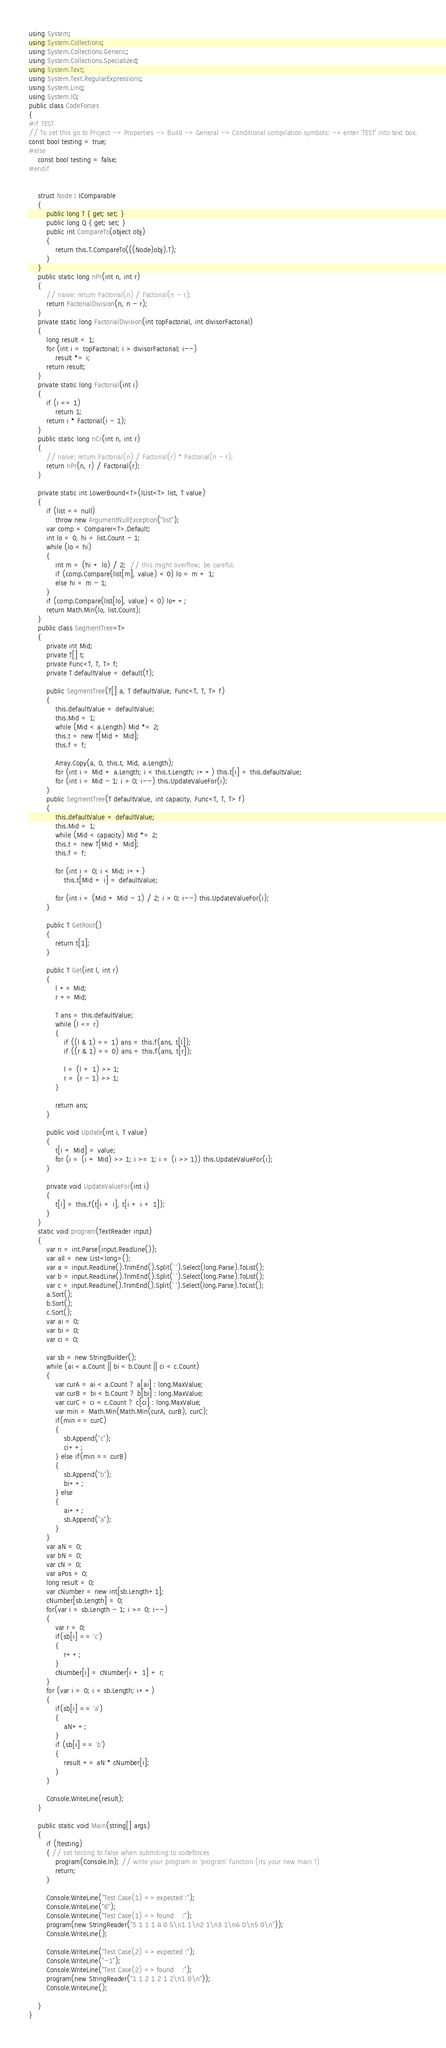<code> <loc_0><loc_0><loc_500><loc_500><_C#_>using System;
using System.Collections;
using System.Collections.Generic;
using System.Collections.Specialized;
using System.Text;
using System.Text.RegularExpressions;
using System.Linq;
using System.IO;
public class CodeForces
{
#if TEST
// To set this go to Project -> Properties -> Build -> General -> Conditional compilation symbols: -> enter 'TEST' into text box.
const bool testing = true;
#else
    const bool testing = false;
#endif


    struct Node : IComparable
    {
        public long T { get; set; }
        public long Q { get; set; }
        public int CompareTo(object obj)
        {
            return this.T.CompareTo(((Node)obj).T);
        }
    }
    public static long nPr(int n, int r)
    {
        // naive: return Factorial(n) / Factorial(n - r);
        return FactorialDivision(n, n - r);
    }
    private static long FactorialDivision(int topFactorial, int divisorFactorial)
    {
        long result = 1;
        for (int i = topFactorial; i > divisorFactorial; i--)
            result *= i;
        return result;
    }
    private static long Factorial(int i)
    {
        if (i <= 1)
            return 1;
        return i * Factorial(i - 1);
    }
    public static long nCr(int n, int r)
    {
        // naive: return Factorial(n) / Factorial(r) * Factorial(n - r);
        return nPr(n, r) / Factorial(r);
    }

    private static int LowerBound<T>(IList<T> list, T value)
    {
        if (list == null)
            throw new ArgumentNullException("list");
        var comp = Comparer<T>.Default;
        int lo = 0, hi = list.Count - 1;
        while (lo < hi)
        {
            int m = (hi + lo) / 2;  // this might overflow; be careful.
            if (comp.Compare(list[m], value) < 0) lo = m + 1;
            else hi = m - 1;
        }
        if (comp.Compare(list[lo], value) < 0) lo++;
        return Math.Min(lo, list.Count);
    }
    public class SegmentTree<T>
    {
        private int Mid;
        private T[] t;
        private Func<T, T, T> f;
        private T defaultValue = default(T);

        public SegmentTree(T[] a, T defaultValue, Func<T, T, T> f)
        {
            this.defaultValue = defaultValue;
            this.Mid = 1;
            while (Mid < a.Length) Mid *= 2;
            this.t = new T[Mid + Mid];
            this.f = f;

            Array.Copy(a, 0, this.t, Mid, a.Length);
            for (int i = Mid + a.Length; i < this.t.Length; i++) this.t[i] = this.defaultValue;
            for (int i = Mid - 1; i > 0; i--) this.UpdateValueFor(i);
        }
        public SegmentTree(T defaultValue, int capacity, Func<T, T, T> f)
        {
            this.defaultValue = defaultValue;
            this.Mid = 1;
            while (Mid < capacity) Mid *= 2;
            this.t = new T[Mid + Mid];
            this.f = f;

            for (int i = 0; i < Mid; i++)
                this.t[Mid + i] = defaultValue;

            for (int i = (Mid + Mid - 1) / 2; i > 0; i--) this.UpdateValueFor(i);
        }

        public T GetRoot()
        {
            return t[1];
        }

        public T Get(int l, int r)
        {
            l += Mid;
            r += Mid;

            T ans = this.defaultValue;
            while (l <= r)
            {
                if ((l & 1) == 1) ans = this.f(ans, t[l]);
                if ((r & 1) == 0) ans = this.f(ans, t[r]);

                l = (l + 1) >> 1;
                r = (r - 1) >> 1;
            }

            return ans;
        }

        public void Update(int i, T value)
        {
            t[i + Mid] = value;
            for (i = (i + Mid) >> 1; i >= 1; i = (i >> 1)) this.UpdateValueFor(i);
        }

        private void UpdateValueFor(int i)
        {
            t[i] = this.f(t[i + i], t[i + i + 1]);
        }
    }
    static void program(TextReader input)
    {
        var n = int.Parse(input.ReadLine());
        var all = new List<long>();
        var a = input.ReadLine().TrimEnd().Split(' ').Select(long.Parse).ToList();
        var b = input.ReadLine().TrimEnd().Split(' ').Select(long.Parse).ToList();
        var c = input.ReadLine().TrimEnd().Split(' ').Select(long.Parse).ToList();
        a.Sort();
        b.Sort();
        c.Sort();
        var ai = 0;
        var bi = 0;
        var ci = 0;
        
        var sb = new StringBuilder();
        while (ai < a.Count || bi < b.Count || ci < c.Count)
        {
            var curA = ai < a.Count ? a[ai] : long.MaxValue;
            var curB = bi < b.Count ? b[bi] : long.MaxValue;
            var curC = ci < c.Count ? c[ci] : long.MaxValue;
            var min = Math.Min(Math.Min(curA, curB), curC);
            if(min == curC)
            {
                sb.Append("c");
                ci++;
            } else if(min == curB)
            {
                sb.Append("b");
                bi++;
            } else
            {
                ai++;
                sb.Append("a");
            }
        }
        var aN = 0;
        var bN = 0;
        var cN = 0;
        var aPos = 0;
        long result = 0;
        var cNumber = new int[sb.Length+1];
        cNumber[sb.Length] = 0;
        for(var i = sb.Length - 1; i >= 0; i--)
        {
            var r = 0;
            if(sb[i] == 'c')
            {
                r++;
            }
            cNumber[i] = cNumber[i + 1] + r;
        }
        for (var i = 0; i < sb.Length; i++)
        {
            if(sb[i] == 'a')
            {
                aN++;
            }
            if (sb[i] == 'b')
            {
                result += aN * cNumber[i];
            }
        }

        Console.WriteLine(result);
    }

    public static void Main(string[] args)
    {
        if (!testing)
        { // set testing to false when submiting to codeforces
            program(Console.In); // write your program in 'program' function (its your new main !)
            return;
        }

        Console.WriteLine("Test Case(1) => expected :");
        Console.WriteLine("6");
        Console.WriteLine("Test Case(1) => found    :");
        program(new StringReader("5 1 1 1 4 0 5\n1 1\n2 1\n3 1\n4 0\n5 0\n"));
        Console.WriteLine();

        Console.WriteLine("Test Case(2) => expected :");
        Console.WriteLine("-1");
        Console.WriteLine("Test Case(2) => found    :");
        program(new StringReader("1 1 2 1 2 1 2\n1 0\n"));
        Console.WriteLine();

    }
}
</code> 